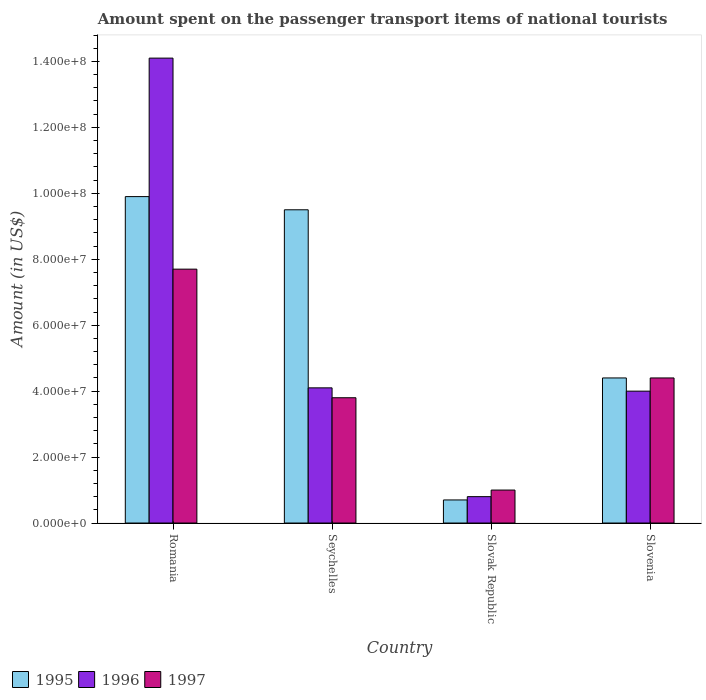How many different coloured bars are there?
Keep it short and to the point. 3. Are the number of bars on each tick of the X-axis equal?
Your response must be concise. Yes. How many bars are there on the 3rd tick from the left?
Ensure brevity in your answer.  3. What is the label of the 1st group of bars from the left?
Keep it short and to the point. Romania. What is the amount spent on the passenger transport items of national tourists in 1995 in Seychelles?
Offer a very short reply. 9.50e+07. Across all countries, what is the maximum amount spent on the passenger transport items of national tourists in 1995?
Your response must be concise. 9.90e+07. In which country was the amount spent on the passenger transport items of national tourists in 1995 maximum?
Your response must be concise. Romania. In which country was the amount spent on the passenger transport items of national tourists in 1995 minimum?
Ensure brevity in your answer.  Slovak Republic. What is the total amount spent on the passenger transport items of national tourists in 1997 in the graph?
Ensure brevity in your answer.  1.69e+08. What is the difference between the amount spent on the passenger transport items of national tourists in 1996 in Slovak Republic and that in Slovenia?
Your answer should be compact. -3.20e+07. What is the difference between the amount spent on the passenger transport items of national tourists in 1995 in Seychelles and the amount spent on the passenger transport items of national tourists in 1997 in Slovak Republic?
Give a very brief answer. 8.50e+07. What is the average amount spent on the passenger transport items of national tourists in 1995 per country?
Your answer should be very brief. 6.12e+07. What is the difference between the amount spent on the passenger transport items of national tourists of/in 1995 and amount spent on the passenger transport items of national tourists of/in 1997 in Seychelles?
Make the answer very short. 5.70e+07. What is the ratio of the amount spent on the passenger transport items of national tourists in 1996 in Romania to that in Slovak Republic?
Offer a terse response. 17.62. Is the amount spent on the passenger transport items of national tourists in 1997 in Seychelles less than that in Slovak Republic?
Provide a succinct answer. No. What is the difference between the highest and the second highest amount spent on the passenger transport items of national tourists in 1997?
Keep it short and to the point. 3.30e+07. What is the difference between the highest and the lowest amount spent on the passenger transport items of national tourists in 1996?
Offer a terse response. 1.33e+08. In how many countries, is the amount spent on the passenger transport items of national tourists in 1996 greater than the average amount spent on the passenger transport items of national tourists in 1996 taken over all countries?
Offer a very short reply. 1. Is the sum of the amount spent on the passenger transport items of national tourists in 1995 in Seychelles and Slovak Republic greater than the maximum amount spent on the passenger transport items of national tourists in 1997 across all countries?
Keep it short and to the point. Yes. What does the 1st bar from the left in Seychelles represents?
Offer a terse response. 1995. What does the 3rd bar from the right in Slovak Republic represents?
Provide a short and direct response. 1995. Is it the case that in every country, the sum of the amount spent on the passenger transport items of national tourists in 1995 and amount spent on the passenger transport items of national tourists in 1996 is greater than the amount spent on the passenger transport items of national tourists in 1997?
Provide a short and direct response. Yes. How many bars are there?
Ensure brevity in your answer.  12. Are all the bars in the graph horizontal?
Give a very brief answer. No. What is the difference between two consecutive major ticks on the Y-axis?
Make the answer very short. 2.00e+07. Does the graph contain grids?
Your answer should be very brief. No. Where does the legend appear in the graph?
Your response must be concise. Bottom left. How many legend labels are there?
Your response must be concise. 3. How are the legend labels stacked?
Offer a very short reply. Horizontal. What is the title of the graph?
Keep it short and to the point. Amount spent on the passenger transport items of national tourists. Does "2002" appear as one of the legend labels in the graph?
Your answer should be very brief. No. What is the label or title of the X-axis?
Provide a short and direct response. Country. What is the Amount (in US$) of 1995 in Romania?
Provide a succinct answer. 9.90e+07. What is the Amount (in US$) in 1996 in Romania?
Give a very brief answer. 1.41e+08. What is the Amount (in US$) of 1997 in Romania?
Ensure brevity in your answer.  7.70e+07. What is the Amount (in US$) in 1995 in Seychelles?
Provide a short and direct response. 9.50e+07. What is the Amount (in US$) of 1996 in Seychelles?
Your response must be concise. 4.10e+07. What is the Amount (in US$) in 1997 in Seychelles?
Ensure brevity in your answer.  3.80e+07. What is the Amount (in US$) in 1995 in Slovak Republic?
Provide a succinct answer. 7.00e+06. What is the Amount (in US$) in 1996 in Slovak Republic?
Offer a very short reply. 8.00e+06. What is the Amount (in US$) of 1997 in Slovak Republic?
Provide a short and direct response. 1.00e+07. What is the Amount (in US$) of 1995 in Slovenia?
Ensure brevity in your answer.  4.40e+07. What is the Amount (in US$) of 1996 in Slovenia?
Give a very brief answer. 4.00e+07. What is the Amount (in US$) in 1997 in Slovenia?
Give a very brief answer. 4.40e+07. Across all countries, what is the maximum Amount (in US$) in 1995?
Keep it short and to the point. 9.90e+07. Across all countries, what is the maximum Amount (in US$) in 1996?
Your answer should be very brief. 1.41e+08. Across all countries, what is the maximum Amount (in US$) of 1997?
Your answer should be compact. 7.70e+07. Across all countries, what is the minimum Amount (in US$) in 1997?
Give a very brief answer. 1.00e+07. What is the total Amount (in US$) in 1995 in the graph?
Offer a terse response. 2.45e+08. What is the total Amount (in US$) in 1996 in the graph?
Offer a terse response. 2.30e+08. What is the total Amount (in US$) of 1997 in the graph?
Ensure brevity in your answer.  1.69e+08. What is the difference between the Amount (in US$) in 1995 in Romania and that in Seychelles?
Offer a very short reply. 4.00e+06. What is the difference between the Amount (in US$) in 1996 in Romania and that in Seychelles?
Your response must be concise. 1.00e+08. What is the difference between the Amount (in US$) of 1997 in Romania and that in Seychelles?
Make the answer very short. 3.90e+07. What is the difference between the Amount (in US$) of 1995 in Romania and that in Slovak Republic?
Make the answer very short. 9.20e+07. What is the difference between the Amount (in US$) of 1996 in Romania and that in Slovak Republic?
Provide a short and direct response. 1.33e+08. What is the difference between the Amount (in US$) of 1997 in Romania and that in Slovak Republic?
Provide a succinct answer. 6.70e+07. What is the difference between the Amount (in US$) of 1995 in Romania and that in Slovenia?
Provide a short and direct response. 5.50e+07. What is the difference between the Amount (in US$) of 1996 in Romania and that in Slovenia?
Offer a very short reply. 1.01e+08. What is the difference between the Amount (in US$) in 1997 in Romania and that in Slovenia?
Provide a succinct answer. 3.30e+07. What is the difference between the Amount (in US$) in 1995 in Seychelles and that in Slovak Republic?
Your response must be concise. 8.80e+07. What is the difference between the Amount (in US$) in 1996 in Seychelles and that in Slovak Republic?
Your answer should be compact. 3.30e+07. What is the difference between the Amount (in US$) of 1997 in Seychelles and that in Slovak Republic?
Your response must be concise. 2.80e+07. What is the difference between the Amount (in US$) of 1995 in Seychelles and that in Slovenia?
Your answer should be very brief. 5.10e+07. What is the difference between the Amount (in US$) in 1996 in Seychelles and that in Slovenia?
Give a very brief answer. 1.00e+06. What is the difference between the Amount (in US$) in 1997 in Seychelles and that in Slovenia?
Your response must be concise. -6.00e+06. What is the difference between the Amount (in US$) of 1995 in Slovak Republic and that in Slovenia?
Provide a succinct answer. -3.70e+07. What is the difference between the Amount (in US$) of 1996 in Slovak Republic and that in Slovenia?
Ensure brevity in your answer.  -3.20e+07. What is the difference between the Amount (in US$) of 1997 in Slovak Republic and that in Slovenia?
Ensure brevity in your answer.  -3.40e+07. What is the difference between the Amount (in US$) of 1995 in Romania and the Amount (in US$) of 1996 in Seychelles?
Provide a short and direct response. 5.80e+07. What is the difference between the Amount (in US$) in 1995 in Romania and the Amount (in US$) in 1997 in Seychelles?
Your answer should be compact. 6.10e+07. What is the difference between the Amount (in US$) of 1996 in Romania and the Amount (in US$) of 1997 in Seychelles?
Offer a terse response. 1.03e+08. What is the difference between the Amount (in US$) of 1995 in Romania and the Amount (in US$) of 1996 in Slovak Republic?
Your answer should be very brief. 9.10e+07. What is the difference between the Amount (in US$) in 1995 in Romania and the Amount (in US$) in 1997 in Slovak Republic?
Offer a terse response. 8.90e+07. What is the difference between the Amount (in US$) in 1996 in Romania and the Amount (in US$) in 1997 in Slovak Republic?
Keep it short and to the point. 1.31e+08. What is the difference between the Amount (in US$) in 1995 in Romania and the Amount (in US$) in 1996 in Slovenia?
Ensure brevity in your answer.  5.90e+07. What is the difference between the Amount (in US$) in 1995 in Romania and the Amount (in US$) in 1997 in Slovenia?
Offer a terse response. 5.50e+07. What is the difference between the Amount (in US$) in 1996 in Romania and the Amount (in US$) in 1997 in Slovenia?
Provide a succinct answer. 9.70e+07. What is the difference between the Amount (in US$) in 1995 in Seychelles and the Amount (in US$) in 1996 in Slovak Republic?
Make the answer very short. 8.70e+07. What is the difference between the Amount (in US$) of 1995 in Seychelles and the Amount (in US$) of 1997 in Slovak Republic?
Give a very brief answer. 8.50e+07. What is the difference between the Amount (in US$) of 1996 in Seychelles and the Amount (in US$) of 1997 in Slovak Republic?
Make the answer very short. 3.10e+07. What is the difference between the Amount (in US$) of 1995 in Seychelles and the Amount (in US$) of 1996 in Slovenia?
Offer a very short reply. 5.50e+07. What is the difference between the Amount (in US$) in 1995 in Seychelles and the Amount (in US$) in 1997 in Slovenia?
Offer a terse response. 5.10e+07. What is the difference between the Amount (in US$) of 1996 in Seychelles and the Amount (in US$) of 1997 in Slovenia?
Your answer should be compact. -3.00e+06. What is the difference between the Amount (in US$) in 1995 in Slovak Republic and the Amount (in US$) in 1996 in Slovenia?
Make the answer very short. -3.30e+07. What is the difference between the Amount (in US$) of 1995 in Slovak Republic and the Amount (in US$) of 1997 in Slovenia?
Make the answer very short. -3.70e+07. What is the difference between the Amount (in US$) in 1996 in Slovak Republic and the Amount (in US$) in 1997 in Slovenia?
Provide a succinct answer. -3.60e+07. What is the average Amount (in US$) of 1995 per country?
Your answer should be very brief. 6.12e+07. What is the average Amount (in US$) of 1996 per country?
Offer a very short reply. 5.75e+07. What is the average Amount (in US$) of 1997 per country?
Provide a succinct answer. 4.22e+07. What is the difference between the Amount (in US$) in 1995 and Amount (in US$) in 1996 in Romania?
Give a very brief answer. -4.20e+07. What is the difference between the Amount (in US$) of 1995 and Amount (in US$) of 1997 in Romania?
Offer a very short reply. 2.20e+07. What is the difference between the Amount (in US$) in 1996 and Amount (in US$) in 1997 in Romania?
Your answer should be compact. 6.40e+07. What is the difference between the Amount (in US$) in 1995 and Amount (in US$) in 1996 in Seychelles?
Make the answer very short. 5.40e+07. What is the difference between the Amount (in US$) in 1995 and Amount (in US$) in 1997 in Seychelles?
Your answer should be very brief. 5.70e+07. What is the difference between the Amount (in US$) of 1995 and Amount (in US$) of 1997 in Slovak Republic?
Keep it short and to the point. -3.00e+06. What is the difference between the Amount (in US$) of 1995 and Amount (in US$) of 1996 in Slovenia?
Provide a succinct answer. 4.00e+06. What is the difference between the Amount (in US$) of 1996 and Amount (in US$) of 1997 in Slovenia?
Offer a very short reply. -4.00e+06. What is the ratio of the Amount (in US$) in 1995 in Romania to that in Seychelles?
Give a very brief answer. 1.04. What is the ratio of the Amount (in US$) in 1996 in Romania to that in Seychelles?
Your answer should be compact. 3.44. What is the ratio of the Amount (in US$) in 1997 in Romania to that in Seychelles?
Offer a terse response. 2.03. What is the ratio of the Amount (in US$) in 1995 in Romania to that in Slovak Republic?
Your answer should be very brief. 14.14. What is the ratio of the Amount (in US$) of 1996 in Romania to that in Slovak Republic?
Make the answer very short. 17.62. What is the ratio of the Amount (in US$) in 1997 in Romania to that in Slovak Republic?
Ensure brevity in your answer.  7.7. What is the ratio of the Amount (in US$) of 1995 in Romania to that in Slovenia?
Provide a short and direct response. 2.25. What is the ratio of the Amount (in US$) in 1996 in Romania to that in Slovenia?
Keep it short and to the point. 3.52. What is the ratio of the Amount (in US$) in 1997 in Romania to that in Slovenia?
Make the answer very short. 1.75. What is the ratio of the Amount (in US$) in 1995 in Seychelles to that in Slovak Republic?
Your answer should be compact. 13.57. What is the ratio of the Amount (in US$) of 1996 in Seychelles to that in Slovak Republic?
Make the answer very short. 5.12. What is the ratio of the Amount (in US$) of 1995 in Seychelles to that in Slovenia?
Make the answer very short. 2.16. What is the ratio of the Amount (in US$) of 1996 in Seychelles to that in Slovenia?
Make the answer very short. 1.02. What is the ratio of the Amount (in US$) in 1997 in Seychelles to that in Slovenia?
Provide a short and direct response. 0.86. What is the ratio of the Amount (in US$) of 1995 in Slovak Republic to that in Slovenia?
Offer a terse response. 0.16. What is the ratio of the Amount (in US$) in 1997 in Slovak Republic to that in Slovenia?
Give a very brief answer. 0.23. What is the difference between the highest and the second highest Amount (in US$) of 1995?
Keep it short and to the point. 4.00e+06. What is the difference between the highest and the second highest Amount (in US$) in 1996?
Your answer should be very brief. 1.00e+08. What is the difference between the highest and the second highest Amount (in US$) in 1997?
Keep it short and to the point. 3.30e+07. What is the difference between the highest and the lowest Amount (in US$) in 1995?
Offer a very short reply. 9.20e+07. What is the difference between the highest and the lowest Amount (in US$) in 1996?
Offer a very short reply. 1.33e+08. What is the difference between the highest and the lowest Amount (in US$) of 1997?
Provide a short and direct response. 6.70e+07. 